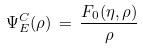<formula> <loc_0><loc_0><loc_500><loc_500>\Psi ^ { C } _ { E } ( \rho ) \, = \, \frac { F _ { 0 } ( \eta , \rho ) } { \rho } \,</formula> 